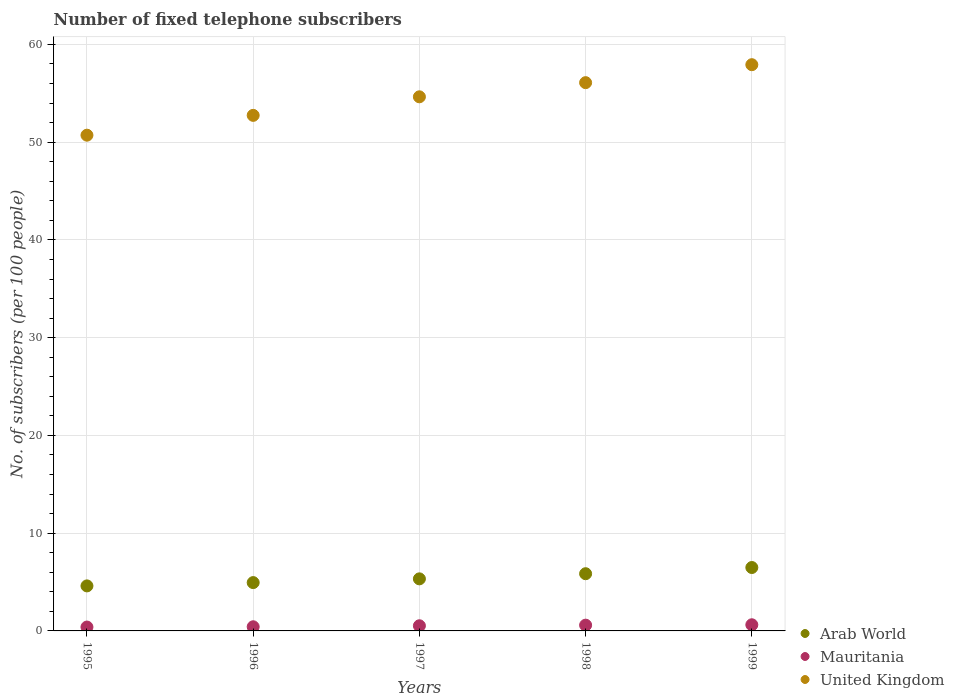How many different coloured dotlines are there?
Keep it short and to the point. 3. Is the number of dotlines equal to the number of legend labels?
Make the answer very short. Yes. What is the number of fixed telephone subscribers in United Kingdom in 1998?
Your answer should be very brief. 56.09. Across all years, what is the maximum number of fixed telephone subscribers in United Kingdom?
Your answer should be very brief. 57.92. Across all years, what is the minimum number of fixed telephone subscribers in United Kingdom?
Make the answer very short. 50.71. What is the total number of fixed telephone subscribers in United Kingdom in the graph?
Offer a terse response. 272.1. What is the difference between the number of fixed telephone subscribers in Arab World in 1997 and that in 1998?
Your answer should be very brief. -0.53. What is the difference between the number of fixed telephone subscribers in Mauritania in 1998 and the number of fixed telephone subscribers in Arab World in 1996?
Ensure brevity in your answer.  -4.35. What is the average number of fixed telephone subscribers in Arab World per year?
Offer a very short reply. 5.44. In the year 1998, what is the difference between the number of fixed telephone subscribers in United Kingdom and number of fixed telephone subscribers in Mauritania?
Keep it short and to the point. 55.5. In how many years, is the number of fixed telephone subscribers in Arab World greater than 50?
Provide a short and direct response. 0. What is the ratio of the number of fixed telephone subscribers in United Kingdom in 1996 to that in 1999?
Your answer should be compact. 0.91. Is the number of fixed telephone subscribers in Mauritania in 1996 less than that in 1999?
Ensure brevity in your answer.  Yes. What is the difference between the highest and the second highest number of fixed telephone subscribers in Mauritania?
Offer a terse response. 0.04. What is the difference between the highest and the lowest number of fixed telephone subscribers in Arab World?
Make the answer very short. 1.88. In how many years, is the number of fixed telephone subscribers in Mauritania greater than the average number of fixed telephone subscribers in Mauritania taken over all years?
Offer a very short reply. 3. Is the number of fixed telephone subscribers in Arab World strictly less than the number of fixed telephone subscribers in United Kingdom over the years?
Make the answer very short. Yes. How many dotlines are there?
Keep it short and to the point. 3. How many years are there in the graph?
Your response must be concise. 5. Does the graph contain any zero values?
Keep it short and to the point. No. Does the graph contain grids?
Offer a terse response. Yes. What is the title of the graph?
Make the answer very short. Number of fixed telephone subscribers. What is the label or title of the X-axis?
Ensure brevity in your answer.  Years. What is the label or title of the Y-axis?
Your answer should be very brief. No. of subscribers (per 100 people). What is the No. of subscribers (per 100 people) of Arab World in 1995?
Give a very brief answer. 4.61. What is the No. of subscribers (per 100 people) in Mauritania in 1995?
Keep it short and to the point. 0.4. What is the No. of subscribers (per 100 people) of United Kingdom in 1995?
Your answer should be very brief. 50.71. What is the No. of subscribers (per 100 people) of Arab World in 1996?
Provide a succinct answer. 4.94. What is the No. of subscribers (per 100 people) of Mauritania in 1996?
Provide a short and direct response. 0.42. What is the No. of subscribers (per 100 people) of United Kingdom in 1996?
Make the answer very short. 52.74. What is the No. of subscribers (per 100 people) of Arab World in 1997?
Make the answer very short. 5.33. What is the No. of subscribers (per 100 people) in Mauritania in 1997?
Your answer should be very brief. 0.53. What is the No. of subscribers (per 100 people) in United Kingdom in 1997?
Provide a short and direct response. 54.64. What is the No. of subscribers (per 100 people) in Arab World in 1998?
Provide a short and direct response. 5.85. What is the No. of subscribers (per 100 people) of Mauritania in 1998?
Ensure brevity in your answer.  0.59. What is the No. of subscribers (per 100 people) of United Kingdom in 1998?
Your response must be concise. 56.09. What is the No. of subscribers (per 100 people) of Arab World in 1999?
Your answer should be compact. 6.49. What is the No. of subscribers (per 100 people) in Mauritania in 1999?
Your answer should be very brief. 0.63. What is the No. of subscribers (per 100 people) in United Kingdom in 1999?
Keep it short and to the point. 57.92. Across all years, what is the maximum No. of subscribers (per 100 people) of Arab World?
Your answer should be very brief. 6.49. Across all years, what is the maximum No. of subscribers (per 100 people) of Mauritania?
Ensure brevity in your answer.  0.63. Across all years, what is the maximum No. of subscribers (per 100 people) in United Kingdom?
Ensure brevity in your answer.  57.92. Across all years, what is the minimum No. of subscribers (per 100 people) in Arab World?
Make the answer very short. 4.61. Across all years, what is the minimum No. of subscribers (per 100 people) in Mauritania?
Your response must be concise. 0.4. Across all years, what is the minimum No. of subscribers (per 100 people) in United Kingdom?
Offer a terse response. 50.71. What is the total No. of subscribers (per 100 people) of Arab World in the graph?
Make the answer very short. 27.21. What is the total No. of subscribers (per 100 people) in Mauritania in the graph?
Make the answer very short. 2.57. What is the total No. of subscribers (per 100 people) in United Kingdom in the graph?
Your response must be concise. 272.1. What is the difference between the No. of subscribers (per 100 people) in Arab World in 1995 and that in 1996?
Offer a terse response. -0.34. What is the difference between the No. of subscribers (per 100 people) of Mauritania in 1995 and that in 1996?
Make the answer very short. -0.03. What is the difference between the No. of subscribers (per 100 people) in United Kingdom in 1995 and that in 1996?
Your response must be concise. -2.03. What is the difference between the No. of subscribers (per 100 people) in Arab World in 1995 and that in 1997?
Your answer should be compact. -0.72. What is the difference between the No. of subscribers (per 100 people) of Mauritania in 1995 and that in 1997?
Give a very brief answer. -0.13. What is the difference between the No. of subscribers (per 100 people) of United Kingdom in 1995 and that in 1997?
Provide a succinct answer. -3.93. What is the difference between the No. of subscribers (per 100 people) of Arab World in 1995 and that in 1998?
Provide a succinct answer. -1.25. What is the difference between the No. of subscribers (per 100 people) in Mauritania in 1995 and that in 1998?
Provide a succinct answer. -0.19. What is the difference between the No. of subscribers (per 100 people) in United Kingdom in 1995 and that in 1998?
Ensure brevity in your answer.  -5.37. What is the difference between the No. of subscribers (per 100 people) of Arab World in 1995 and that in 1999?
Offer a terse response. -1.88. What is the difference between the No. of subscribers (per 100 people) of Mauritania in 1995 and that in 1999?
Ensure brevity in your answer.  -0.23. What is the difference between the No. of subscribers (per 100 people) in United Kingdom in 1995 and that in 1999?
Offer a terse response. -7.21. What is the difference between the No. of subscribers (per 100 people) of Arab World in 1996 and that in 1997?
Ensure brevity in your answer.  -0.38. What is the difference between the No. of subscribers (per 100 people) of Mauritania in 1996 and that in 1997?
Ensure brevity in your answer.  -0.1. What is the difference between the No. of subscribers (per 100 people) in United Kingdom in 1996 and that in 1997?
Provide a succinct answer. -1.9. What is the difference between the No. of subscribers (per 100 people) of Arab World in 1996 and that in 1998?
Your answer should be compact. -0.91. What is the difference between the No. of subscribers (per 100 people) in Mauritania in 1996 and that in 1998?
Your answer should be compact. -0.16. What is the difference between the No. of subscribers (per 100 people) in United Kingdom in 1996 and that in 1998?
Provide a short and direct response. -3.35. What is the difference between the No. of subscribers (per 100 people) of Arab World in 1996 and that in 1999?
Offer a terse response. -1.54. What is the difference between the No. of subscribers (per 100 people) of Mauritania in 1996 and that in 1999?
Your answer should be very brief. -0.2. What is the difference between the No. of subscribers (per 100 people) in United Kingdom in 1996 and that in 1999?
Offer a terse response. -5.18. What is the difference between the No. of subscribers (per 100 people) in Arab World in 1997 and that in 1998?
Your answer should be very brief. -0.53. What is the difference between the No. of subscribers (per 100 people) of Mauritania in 1997 and that in 1998?
Offer a terse response. -0.06. What is the difference between the No. of subscribers (per 100 people) in United Kingdom in 1997 and that in 1998?
Provide a succinct answer. -1.45. What is the difference between the No. of subscribers (per 100 people) of Arab World in 1997 and that in 1999?
Give a very brief answer. -1.16. What is the difference between the No. of subscribers (per 100 people) of Mauritania in 1997 and that in 1999?
Provide a succinct answer. -0.1. What is the difference between the No. of subscribers (per 100 people) of United Kingdom in 1997 and that in 1999?
Ensure brevity in your answer.  -3.29. What is the difference between the No. of subscribers (per 100 people) of Arab World in 1998 and that in 1999?
Give a very brief answer. -0.63. What is the difference between the No. of subscribers (per 100 people) of Mauritania in 1998 and that in 1999?
Your response must be concise. -0.04. What is the difference between the No. of subscribers (per 100 people) of United Kingdom in 1998 and that in 1999?
Provide a short and direct response. -1.84. What is the difference between the No. of subscribers (per 100 people) in Arab World in 1995 and the No. of subscribers (per 100 people) in Mauritania in 1996?
Your response must be concise. 4.18. What is the difference between the No. of subscribers (per 100 people) in Arab World in 1995 and the No. of subscribers (per 100 people) in United Kingdom in 1996?
Provide a short and direct response. -48.13. What is the difference between the No. of subscribers (per 100 people) in Mauritania in 1995 and the No. of subscribers (per 100 people) in United Kingdom in 1996?
Your response must be concise. -52.34. What is the difference between the No. of subscribers (per 100 people) of Arab World in 1995 and the No. of subscribers (per 100 people) of Mauritania in 1997?
Keep it short and to the point. 4.08. What is the difference between the No. of subscribers (per 100 people) in Arab World in 1995 and the No. of subscribers (per 100 people) in United Kingdom in 1997?
Give a very brief answer. -50.03. What is the difference between the No. of subscribers (per 100 people) of Mauritania in 1995 and the No. of subscribers (per 100 people) of United Kingdom in 1997?
Your answer should be very brief. -54.24. What is the difference between the No. of subscribers (per 100 people) of Arab World in 1995 and the No. of subscribers (per 100 people) of Mauritania in 1998?
Offer a very short reply. 4.02. What is the difference between the No. of subscribers (per 100 people) in Arab World in 1995 and the No. of subscribers (per 100 people) in United Kingdom in 1998?
Keep it short and to the point. -51.48. What is the difference between the No. of subscribers (per 100 people) in Mauritania in 1995 and the No. of subscribers (per 100 people) in United Kingdom in 1998?
Give a very brief answer. -55.69. What is the difference between the No. of subscribers (per 100 people) in Arab World in 1995 and the No. of subscribers (per 100 people) in Mauritania in 1999?
Give a very brief answer. 3.98. What is the difference between the No. of subscribers (per 100 people) in Arab World in 1995 and the No. of subscribers (per 100 people) in United Kingdom in 1999?
Offer a very short reply. -53.32. What is the difference between the No. of subscribers (per 100 people) of Mauritania in 1995 and the No. of subscribers (per 100 people) of United Kingdom in 1999?
Your response must be concise. -57.53. What is the difference between the No. of subscribers (per 100 people) of Arab World in 1996 and the No. of subscribers (per 100 people) of Mauritania in 1997?
Your answer should be compact. 4.42. What is the difference between the No. of subscribers (per 100 people) in Arab World in 1996 and the No. of subscribers (per 100 people) in United Kingdom in 1997?
Provide a short and direct response. -49.69. What is the difference between the No. of subscribers (per 100 people) in Mauritania in 1996 and the No. of subscribers (per 100 people) in United Kingdom in 1997?
Provide a short and direct response. -54.21. What is the difference between the No. of subscribers (per 100 people) in Arab World in 1996 and the No. of subscribers (per 100 people) in Mauritania in 1998?
Give a very brief answer. 4.35. What is the difference between the No. of subscribers (per 100 people) of Arab World in 1996 and the No. of subscribers (per 100 people) of United Kingdom in 1998?
Give a very brief answer. -51.14. What is the difference between the No. of subscribers (per 100 people) of Mauritania in 1996 and the No. of subscribers (per 100 people) of United Kingdom in 1998?
Your answer should be compact. -55.66. What is the difference between the No. of subscribers (per 100 people) of Arab World in 1996 and the No. of subscribers (per 100 people) of Mauritania in 1999?
Keep it short and to the point. 4.31. What is the difference between the No. of subscribers (per 100 people) in Arab World in 1996 and the No. of subscribers (per 100 people) in United Kingdom in 1999?
Make the answer very short. -52.98. What is the difference between the No. of subscribers (per 100 people) in Mauritania in 1996 and the No. of subscribers (per 100 people) in United Kingdom in 1999?
Your answer should be very brief. -57.5. What is the difference between the No. of subscribers (per 100 people) in Arab World in 1997 and the No. of subscribers (per 100 people) in Mauritania in 1998?
Your answer should be very brief. 4.74. What is the difference between the No. of subscribers (per 100 people) in Arab World in 1997 and the No. of subscribers (per 100 people) in United Kingdom in 1998?
Provide a short and direct response. -50.76. What is the difference between the No. of subscribers (per 100 people) in Mauritania in 1997 and the No. of subscribers (per 100 people) in United Kingdom in 1998?
Your response must be concise. -55.56. What is the difference between the No. of subscribers (per 100 people) of Arab World in 1997 and the No. of subscribers (per 100 people) of Mauritania in 1999?
Offer a very short reply. 4.7. What is the difference between the No. of subscribers (per 100 people) of Arab World in 1997 and the No. of subscribers (per 100 people) of United Kingdom in 1999?
Provide a short and direct response. -52.6. What is the difference between the No. of subscribers (per 100 people) in Mauritania in 1997 and the No. of subscribers (per 100 people) in United Kingdom in 1999?
Give a very brief answer. -57.4. What is the difference between the No. of subscribers (per 100 people) of Arab World in 1998 and the No. of subscribers (per 100 people) of Mauritania in 1999?
Give a very brief answer. 5.22. What is the difference between the No. of subscribers (per 100 people) in Arab World in 1998 and the No. of subscribers (per 100 people) in United Kingdom in 1999?
Make the answer very short. -52.07. What is the difference between the No. of subscribers (per 100 people) in Mauritania in 1998 and the No. of subscribers (per 100 people) in United Kingdom in 1999?
Ensure brevity in your answer.  -57.33. What is the average No. of subscribers (per 100 people) in Arab World per year?
Make the answer very short. 5.44. What is the average No. of subscribers (per 100 people) of Mauritania per year?
Give a very brief answer. 0.51. What is the average No. of subscribers (per 100 people) of United Kingdom per year?
Ensure brevity in your answer.  54.42. In the year 1995, what is the difference between the No. of subscribers (per 100 people) in Arab World and No. of subscribers (per 100 people) in Mauritania?
Your response must be concise. 4.21. In the year 1995, what is the difference between the No. of subscribers (per 100 people) in Arab World and No. of subscribers (per 100 people) in United Kingdom?
Your answer should be very brief. -46.11. In the year 1995, what is the difference between the No. of subscribers (per 100 people) in Mauritania and No. of subscribers (per 100 people) in United Kingdom?
Offer a terse response. -50.32. In the year 1996, what is the difference between the No. of subscribers (per 100 people) of Arab World and No. of subscribers (per 100 people) of Mauritania?
Keep it short and to the point. 4.52. In the year 1996, what is the difference between the No. of subscribers (per 100 people) of Arab World and No. of subscribers (per 100 people) of United Kingdom?
Your answer should be compact. -47.8. In the year 1996, what is the difference between the No. of subscribers (per 100 people) of Mauritania and No. of subscribers (per 100 people) of United Kingdom?
Offer a very short reply. -52.31. In the year 1997, what is the difference between the No. of subscribers (per 100 people) in Arab World and No. of subscribers (per 100 people) in Mauritania?
Keep it short and to the point. 4.8. In the year 1997, what is the difference between the No. of subscribers (per 100 people) in Arab World and No. of subscribers (per 100 people) in United Kingdom?
Your answer should be compact. -49.31. In the year 1997, what is the difference between the No. of subscribers (per 100 people) in Mauritania and No. of subscribers (per 100 people) in United Kingdom?
Give a very brief answer. -54.11. In the year 1998, what is the difference between the No. of subscribers (per 100 people) in Arab World and No. of subscribers (per 100 people) in Mauritania?
Keep it short and to the point. 5.26. In the year 1998, what is the difference between the No. of subscribers (per 100 people) in Arab World and No. of subscribers (per 100 people) in United Kingdom?
Ensure brevity in your answer.  -50.23. In the year 1998, what is the difference between the No. of subscribers (per 100 people) in Mauritania and No. of subscribers (per 100 people) in United Kingdom?
Offer a terse response. -55.5. In the year 1999, what is the difference between the No. of subscribers (per 100 people) in Arab World and No. of subscribers (per 100 people) in Mauritania?
Your answer should be compact. 5.86. In the year 1999, what is the difference between the No. of subscribers (per 100 people) of Arab World and No. of subscribers (per 100 people) of United Kingdom?
Offer a terse response. -51.44. In the year 1999, what is the difference between the No. of subscribers (per 100 people) in Mauritania and No. of subscribers (per 100 people) in United Kingdom?
Make the answer very short. -57.29. What is the ratio of the No. of subscribers (per 100 people) of Arab World in 1995 to that in 1996?
Your answer should be very brief. 0.93. What is the ratio of the No. of subscribers (per 100 people) in Mauritania in 1995 to that in 1996?
Keep it short and to the point. 0.93. What is the ratio of the No. of subscribers (per 100 people) of United Kingdom in 1995 to that in 1996?
Offer a very short reply. 0.96. What is the ratio of the No. of subscribers (per 100 people) in Arab World in 1995 to that in 1997?
Your response must be concise. 0.86. What is the ratio of the No. of subscribers (per 100 people) in Mauritania in 1995 to that in 1997?
Offer a very short reply. 0.75. What is the ratio of the No. of subscribers (per 100 people) in United Kingdom in 1995 to that in 1997?
Ensure brevity in your answer.  0.93. What is the ratio of the No. of subscribers (per 100 people) of Arab World in 1995 to that in 1998?
Your answer should be compact. 0.79. What is the ratio of the No. of subscribers (per 100 people) of Mauritania in 1995 to that in 1998?
Offer a terse response. 0.67. What is the ratio of the No. of subscribers (per 100 people) of United Kingdom in 1995 to that in 1998?
Offer a very short reply. 0.9. What is the ratio of the No. of subscribers (per 100 people) in Arab World in 1995 to that in 1999?
Your answer should be compact. 0.71. What is the ratio of the No. of subscribers (per 100 people) in Mauritania in 1995 to that in 1999?
Your answer should be compact. 0.63. What is the ratio of the No. of subscribers (per 100 people) in United Kingdom in 1995 to that in 1999?
Offer a very short reply. 0.88. What is the ratio of the No. of subscribers (per 100 people) in Arab World in 1996 to that in 1997?
Your response must be concise. 0.93. What is the ratio of the No. of subscribers (per 100 people) of Mauritania in 1996 to that in 1997?
Make the answer very short. 0.81. What is the ratio of the No. of subscribers (per 100 people) of United Kingdom in 1996 to that in 1997?
Give a very brief answer. 0.97. What is the ratio of the No. of subscribers (per 100 people) of Arab World in 1996 to that in 1998?
Provide a succinct answer. 0.84. What is the ratio of the No. of subscribers (per 100 people) of Mauritania in 1996 to that in 1998?
Ensure brevity in your answer.  0.72. What is the ratio of the No. of subscribers (per 100 people) of United Kingdom in 1996 to that in 1998?
Offer a terse response. 0.94. What is the ratio of the No. of subscribers (per 100 people) in Arab World in 1996 to that in 1999?
Offer a very short reply. 0.76. What is the ratio of the No. of subscribers (per 100 people) in Mauritania in 1996 to that in 1999?
Give a very brief answer. 0.68. What is the ratio of the No. of subscribers (per 100 people) in United Kingdom in 1996 to that in 1999?
Your answer should be very brief. 0.91. What is the ratio of the No. of subscribers (per 100 people) in Arab World in 1997 to that in 1998?
Keep it short and to the point. 0.91. What is the ratio of the No. of subscribers (per 100 people) of Mauritania in 1997 to that in 1998?
Provide a succinct answer. 0.89. What is the ratio of the No. of subscribers (per 100 people) of United Kingdom in 1997 to that in 1998?
Give a very brief answer. 0.97. What is the ratio of the No. of subscribers (per 100 people) in Arab World in 1997 to that in 1999?
Your answer should be compact. 0.82. What is the ratio of the No. of subscribers (per 100 people) of Mauritania in 1997 to that in 1999?
Offer a terse response. 0.84. What is the ratio of the No. of subscribers (per 100 people) of United Kingdom in 1997 to that in 1999?
Your response must be concise. 0.94. What is the ratio of the No. of subscribers (per 100 people) of Arab World in 1998 to that in 1999?
Ensure brevity in your answer.  0.9. What is the ratio of the No. of subscribers (per 100 people) of Mauritania in 1998 to that in 1999?
Provide a succinct answer. 0.94. What is the ratio of the No. of subscribers (per 100 people) of United Kingdom in 1998 to that in 1999?
Provide a short and direct response. 0.97. What is the difference between the highest and the second highest No. of subscribers (per 100 people) in Arab World?
Provide a short and direct response. 0.63. What is the difference between the highest and the second highest No. of subscribers (per 100 people) of Mauritania?
Your answer should be very brief. 0.04. What is the difference between the highest and the second highest No. of subscribers (per 100 people) in United Kingdom?
Make the answer very short. 1.84. What is the difference between the highest and the lowest No. of subscribers (per 100 people) of Arab World?
Your response must be concise. 1.88. What is the difference between the highest and the lowest No. of subscribers (per 100 people) in Mauritania?
Your answer should be very brief. 0.23. What is the difference between the highest and the lowest No. of subscribers (per 100 people) in United Kingdom?
Keep it short and to the point. 7.21. 